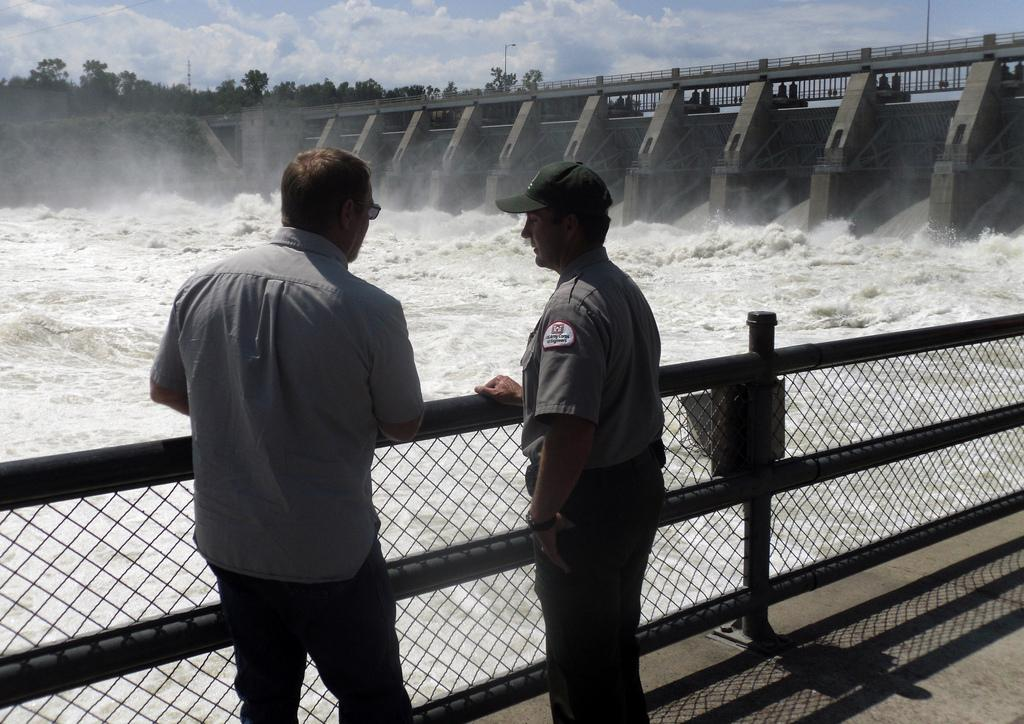How many people are in the foreground of the image? There are two persons standing in the foreground of the image. What can be seen in the image besides the people? There is a fencing, a dam, water, and trees visible in the image. What is the main structure in the background of the image? There is a dam in the background of the image. What type of natural environment is visible in the image? The image features trees and water in the background. What type of sink is visible in the image? There is no sink present in the image. What is the name of the dam in the background of the image? The provided facts do not include the name of the dam, so it cannot be determined from the image. 